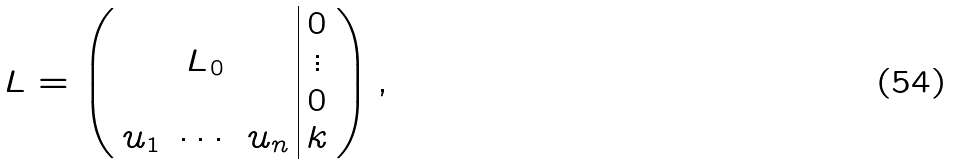<formula> <loc_0><loc_0><loc_500><loc_500>L = \left ( \begin{array} { c c c | c } & & & 0 \\ & L _ { 0 } & & \vdots \\ & & & 0 \\ u _ { 1 } & \cdots & u _ { n } & k \end{array} \right ) ,</formula> 